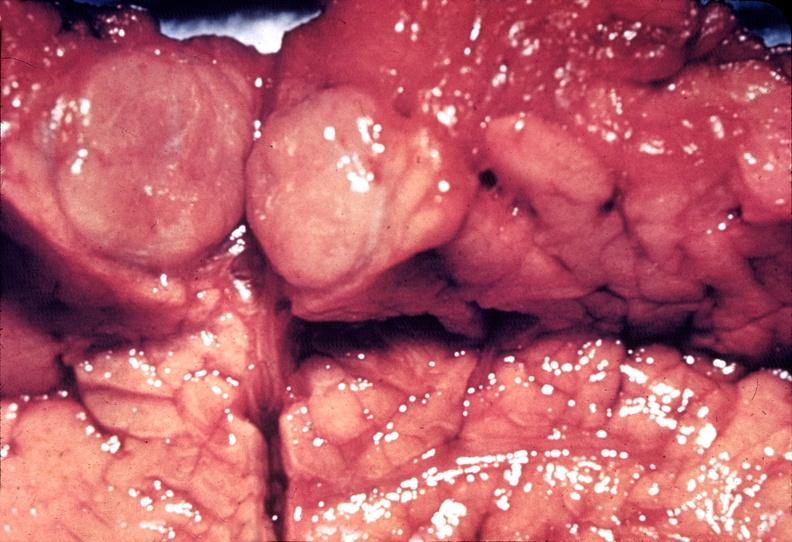s x-ray of femoral heads present?
Answer the question using a single word or phrase. No 